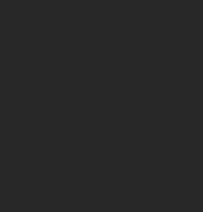Convert code to text. <code><loc_0><loc_0><loc_500><loc_500><_SQL_>  </code> 